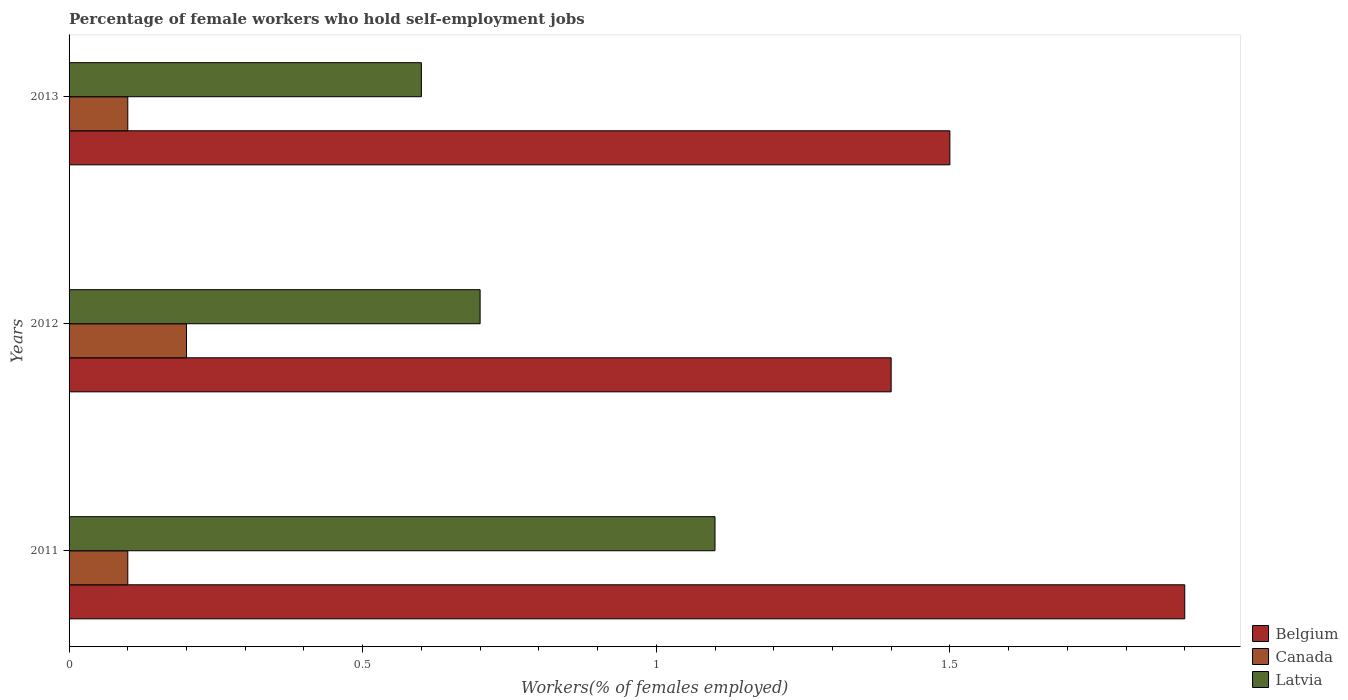How many different coloured bars are there?
Keep it short and to the point. 3. Are the number of bars per tick equal to the number of legend labels?
Ensure brevity in your answer.  Yes. Are the number of bars on each tick of the Y-axis equal?
Offer a very short reply. Yes. How many bars are there on the 3rd tick from the top?
Provide a short and direct response. 3. What is the label of the 3rd group of bars from the top?
Provide a short and direct response. 2011. In how many cases, is the number of bars for a given year not equal to the number of legend labels?
Your answer should be compact. 0. What is the percentage of self-employed female workers in Belgium in 2011?
Ensure brevity in your answer.  1.9. Across all years, what is the maximum percentage of self-employed female workers in Canada?
Give a very brief answer. 0.2. Across all years, what is the minimum percentage of self-employed female workers in Belgium?
Make the answer very short. 1.4. What is the total percentage of self-employed female workers in Belgium in the graph?
Give a very brief answer. 4.8. What is the difference between the percentage of self-employed female workers in Belgium in 2011 and that in 2013?
Ensure brevity in your answer.  0.4. What is the difference between the percentage of self-employed female workers in Canada in 2013 and the percentage of self-employed female workers in Latvia in 2012?
Ensure brevity in your answer.  -0.6. What is the average percentage of self-employed female workers in Latvia per year?
Your answer should be very brief. 0.8. In the year 2011, what is the difference between the percentage of self-employed female workers in Latvia and percentage of self-employed female workers in Belgium?
Your response must be concise. -0.8. Is the difference between the percentage of self-employed female workers in Latvia in 2012 and 2013 greater than the difference between the percentage of self-employed female workers in Belgium in 2012 and 2013?
Provide a short and direct response. Yes. What is the difference between the highest and the second highest percentage of self-employed female workers in Latvia?
Give a very brief answer. 0.4. What is the difference between the highest and the lowest percentage of self-employed female workers in Latvia?
Make the answer very short. 0.5. What does the 1st bar from the top in 2011 represents?
Your answer should be compact. Latvia. What does the 3rd bar from the bottom in 2011 represents?
Give a very brief answer. Latvia. Is it the case that in every year, the sum of the percentage of self-employed female workers in Belgium and percentage of self-employed female workers in Canada is greater than the percentage of self-employed female workers in Latvia?
Your answer should be compact. Yes. What is the difference between two consecutive major ticks on the X-axis?
Your response must be concise. 0.5. Does the graph contain any zero values?
Make the answer very short. No. Does the graph contain grids?
Your response must be concise. No. Where does the legend appear in the graph?
Your response must be concise. Bottom right. What is the title of the graph?
Your answer should be compact. Percentage of female workers who hold self-employment jobs. What is the label or title of the X-axis?
Your answer should be compact. Workers(% of females employed). What is the label or title of the Y-axis?
Your answer should be very brief. Years. What is the Workers(% of females employed) in Belgium in 2011?
Offer a very short reply. 1.9. What is the Workers(% of females employed) of Canada in 2011?
Your response must be concise. 0.1. What is the Workers(% of females employed) in Latvia in 2011?
Provide a short and direct response. 1.1. What is the Workers(% of females employed) of Belgium in 2012?
Give a very brief answer. 1.4. What is the Workers(% of females employed) in Canada in 2012?
Offer a very short reply. 0.2. What is the Workers(% of females employed) of Latvia in 2012?
Your response must be concise. 0.7. What is the Workers(% of females employed) in Canada in 2013?
Make the answer very short. 0.1. What is the Workers(% of females employed) of Latvia in 2013?
Offer a very short reply. 0.6. Across all years, what is the maximum Workers(% of females employed) of Belgium?
Keep it short and to the point. 1.9. Across all years, what is the maximum Workers(% of females employed) of Canada?
Your answer should be very brief. 0.2. Across all years, what is the maximum Workers(% of females employed) of Latvia?
Provide a short and direct response. 1.1. Across all years, what is the minimum Workers(% of females employed) in Belgium?
Offer a very short reply. 1.4. Across all years, what is the minimum Workers(% of females employed) in Canada?
Your answer should be very brief. 0.1. Across all years, what is the minimum Workers(% of females employed) of Latvia?
Give a very brief answer. 0.6. What is the total Workers(% of females employed) of Canada in the graph?
Give a very brief answer. 0.4. What is the total Workers(% of females employed) in Latvia in the graph?
Provide a short and direct response. 2.4. What is the difference between the Workers(% of females employed) of Latvia in 2011 and that in 2013?
Offer a terse response. 0.5. What is the difference between the Workers(% of females employed) in Canada in 2012 and that in 2013?
Offer a very short reply. 0.1. What is the difference between the Workers(% of females employed) of Latvia in 2012 and that in 2013?
Provide a succinct answer. 0.1. What is the difference between the Workers(% of females employed) in Belgium in 2011 and the Workers(% of females employed) in Latvia in 2012?
Give a very brief answer. 1.2. What is the difference between the Workers(% of females employed) in Canada in 2011 and the Workers(% of females employed) in Latvia in 2012?
Your answer should be compact. -0.6. What is the difference between the Workers(% of females employed) of Belgium in 2011 and the Workers(% of females employed) of Latvia in 2013?
Ensure brevity in your answer.  1.3. What is the difference between the Workers(% of females employed) in Belgium in 2012 and the Workers(% of females employed) in Latvia in 2013?
Your response must be concise. 0.8. What is the difference between the Workers(% of females employed) of Canada in 2012 and the Workers(% of females employed) of Latvia in 2013?
Provide a succinct answer. -0.4. What is the average Workers(% of females employed) of Belgium per year?
Make the answer very short. 1.6. What is the average Workers(% of females employed) of Canada per year?
Offer a terse response. 0.13. What is the average Workers(% of females employed) in Latvia per year?
Provide a succinct answer. 0.8. In the year 2011, what is the difference between the Workers(% of females employed) in Belgium and Workers(% of females employed) in Canada?
Your response must be concise. 1.8. In the year 2011, what is the difference between the Workers(% of females employed) in Belgium and Workers(% of females employed) in Latvia?
Give a very brief answer. 0.8. In the year 2012, what is the difference between the Workers(% of females employed) of Belgium and Workers(% of females employed) of Canada?
Make the answer very short. 1.2. In the year 2013, what is the difference between the Workers(% of females employed) of Belgium and Workers(% of females employed) of Latvia?
Your answer should be compact. 0.9. In the year 2013, what is the difference between the Workers(% of females employed) in Canada and Workers(% of females employed) in Latvia?
Offer a very short reply. -0.5. What is the ratio of the Workers(% of females employed) of Belgium in 2011 to that in 2012?
Your response must be concise. 1.36. What is the ratio of the Workers(% of females employed) in Latvia in 2011 to that in 2012?
Offer a terse response. 1.57. What is the ratio of the Workers(% of females employed) of Belgium in 2011 to that in 2013?
Make the answer very short. 1.27. What is the ratio of the Workers(% of females employed) in Canada in 2011 to that in 2013?
Give a very brief answer. 1. What is the ratio of the Workers(% of females employed) in Latvia in 2011 to that in 2013?
Ensure brevity in your answer.  1.83. What is the ratio of the Workers(% of females employed) in Canada in 2012 to that in 2013?
Offer a terse response. 2. What is the difference between the highest and the second highest Workers(% of females employed) of Belgium?
Give a very brief answer. 0.4. What is the difference between the highest and the lowest Workers(% of females employed) in Canada?
Your answer should be compact. 0.1. What is the difference between the highest and the lowest Workers(% of females employed) in Latvia?
Ensure brevity in your answer.  0.5. 